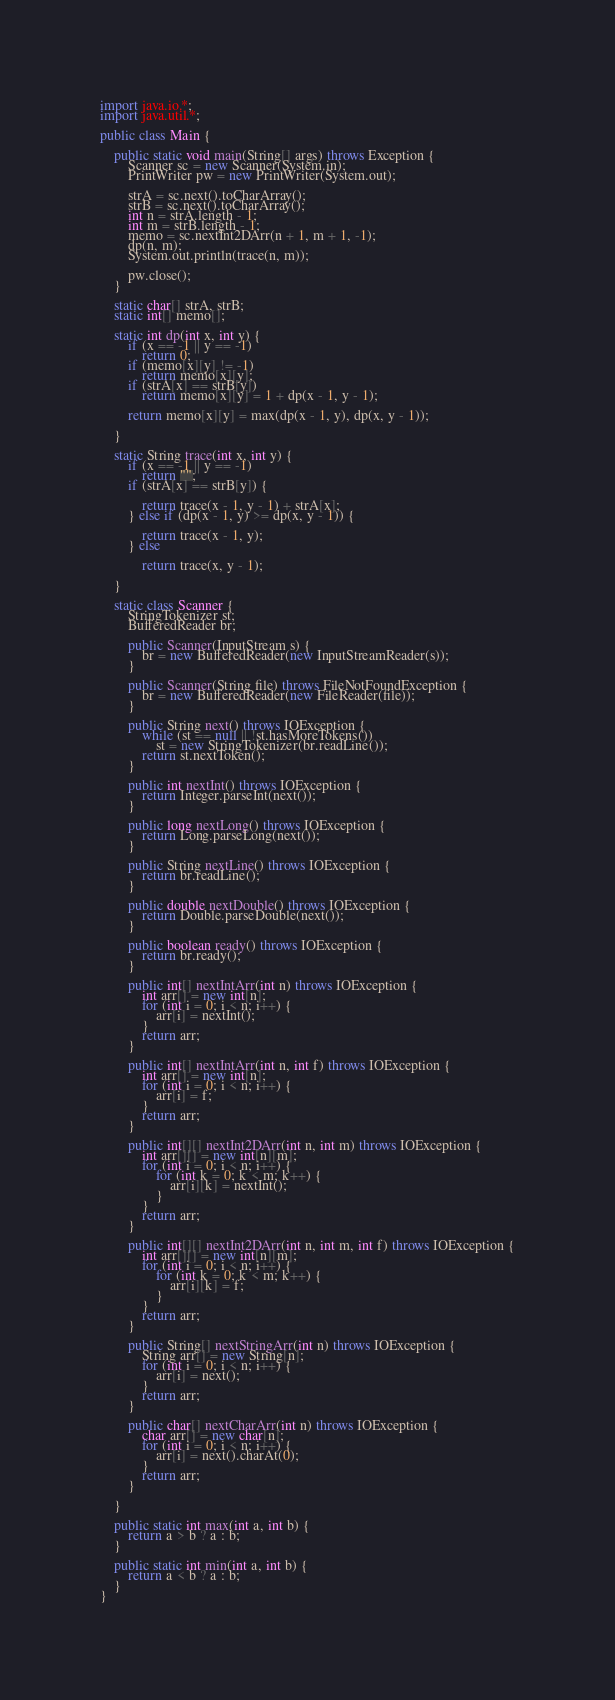Convert code to text. <code><loc_0><loc_0><loc_500><loc_500><_Java_>import java.io.*;
import java.util.*;

public class Main {

	public static void main(String[] args) throws Exception {
		Scanner sc = new Scanner(System.in);
		PrintWriter pw = new PrintWriter(System.out);

		strA = sc.next().toCharArray();
		strB = sc.next().toCharArray();
		int n = strA.length - 1;
		int m = strB.length - 1;
		memo = sc.nextInt2DArr(n + 1, m + 1, -1);
		dp(n, m);
		System.out.println(trace(n, m));

		pw.close();
	}

	static char[] strA, strB;
	static int[] memo[];

	static int dp(int x, int y) {
		if (x == -1 || y == -1)
			return 0;
		if (memo[x][y] != -1)
			return memo[x][y];
		if (strA[x] == strB[y])
			return memo[x][y] = 1 + dp(x - 1, y - 1);

		return memo[x][y] = max(dp(x - 1, y), dp(x, y - 1));

	}

	static String trace(int x, int y) {
		if (x == -1 || y == -1)
			return "";
		if (strA[x] == strB[y]) {

			return trace(x - 1, y - 1) + strA[x];
		} else if (dp(x - 1, y) >= dp(x, y - 1)) {

			return trace(x - 1, y);
		} else

			return trace(x, y - 1);

	}

	static class Scanner {
		StringTokenizer st;
		BufferedReader br;

		public Scanner(InputStream s) {
			br = new BufferedReader(new InputStreamReader(s));
		}

		public Scanner(String file) throws FileNotFoundException {
			br = new BufferedReader(new FileReader(file));
		}

		public String next() throws IOException {
			while (st == null || !st.hasMoreTokens())
				st = new StringTokenizer(br.readLine());
			return st.nextToken();
		}

		public int nextInt() throws IOException {
			return Integer.parseInt(next());
		}

		public long nextLong() throws IOException {
			return Long.parseLong(next());
		}

		public String nextLine() throws IOException {
			return br.readLine();
		}

		public double nextDouble() throws IOException {
			return Double.parseDouble(next());
		}

		public boolean ready() throws IOException {
			return br.ready();
		}

		public int[] nextIntArr(int n) throws IOException {
			int arr[] = new int[n];
			for (int i = 0; i < n; i++) {
				arr[i] = nextInt();
			}
			return arr;
		}

		public int[] nextIntArr(int n, int f) throws IOException {
			int arr[] = new int[n];
			for (int i = 0; i < n; i++) {
				arr[i] = f;
			}
			return arr;
		}

		public int[][] nextInt2DArr(int n, int m) throws IOException {
			int arr[][] = new int[n][m];
			for (int i = 0; i < n; i++) {
				for (int k = 0; k < m; k++) {
					arr[i][k] = nextInt();
				}
			}
			return arr;
		}

		public int[][] nextInt2DArr(int n, int m, int f) throws IOException {
			int arr[][] = new int[n][m];
			for (int i = 0; i < n; i++) {
				for (int k = 0; k < m; k++) {
					arr[i][k] = f;
				}
			}
			return arr;
		}

		public String[] nextStringArr(int n) throws IOException {
			String arr[] = new String[n];
			for (int i = 0; i < n; i++) {
				arr[i] = next();
			}
			return arr;
		}

		public char[] nextCharArr(int n) throws IOException {
			char arr[] = new char[n];
			for (int i = 0; i < n; i++) {
				arr[i] = next().charAt(0);
			}
			return arr;
		}

	}

	public static int max(int a, int b) {
		return a > b ? a : b;
	}

	public static int min(int a, int b) {
		return a < b ? a : b;
	}
}</code> 